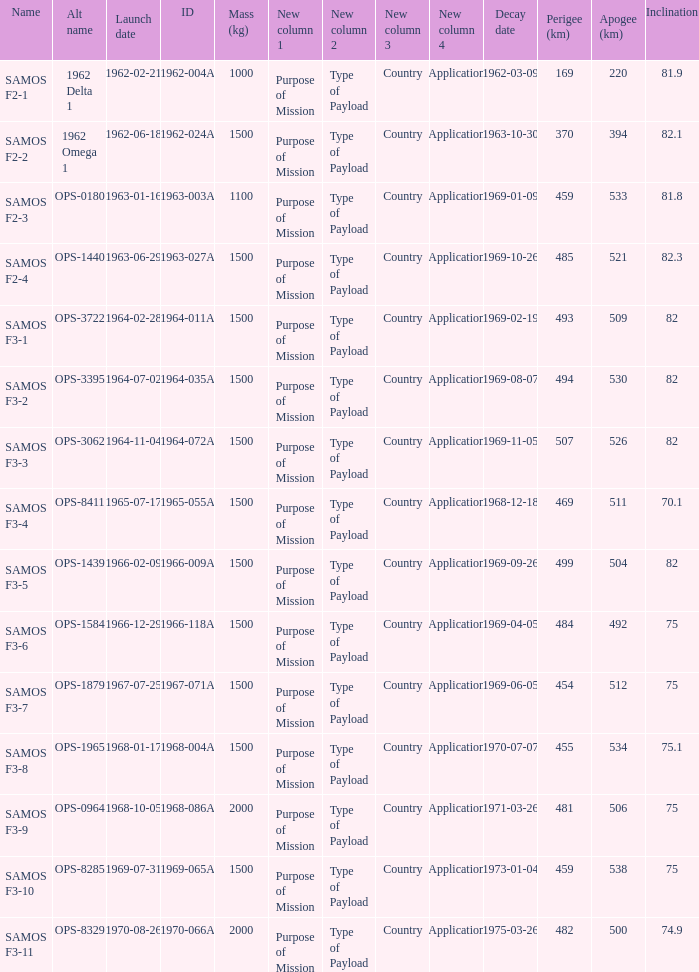What is the inclination when the alt name is OPS-1584? 75.0. 